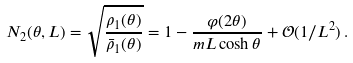<formula> <loc_0><loc_0><loc_500><loc_500>N _ { 2 } ( \theta , L ) = \sqrt { \frac { \rho _ { 1 } ( \theta ) } { \bar { \rho } _ { 1 } ( \theta ) } } = 1 - \frac { \varphi ( 2 \theta ) } { m L \cosh \theta } + \mathcal { O } ( 1 / L ^ { 2 } ) \, .</formula> 